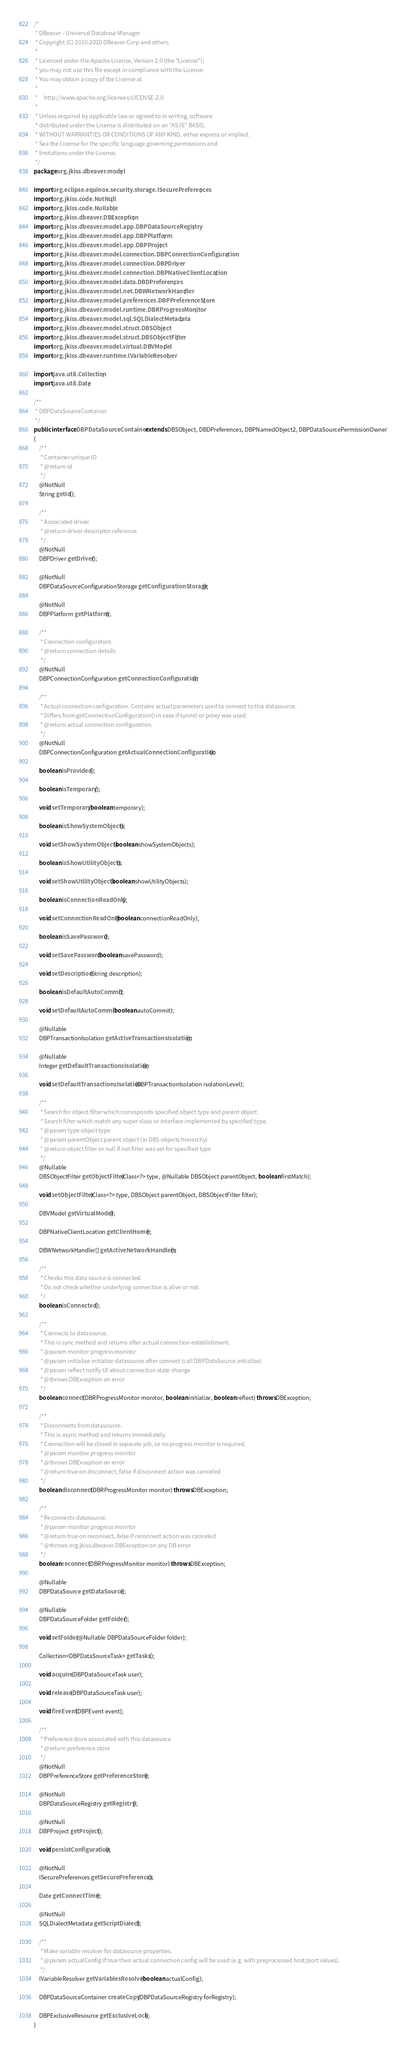<code> <loc_0><loc_0><loc_500><loc_500><_Java_>/*
 * DBeaver - Universal Database Manager
 * Copyright (C) 2010-2020 DBeaver Corp and others
 *
 * Licensed under the Apache License, Version 2.0 (the "License");
 * you may not use this file except in compliance with the License.
 * You may obtain a copy of the License at
 *
 *     http://www.apache.org/licenses/LICENSE-2.0
 *
 * Unless required by applicable law or agreed to in writing, software
 * distributed under the License is distributed on an "AS IS" BASIS,
 * WITHOUT WARRANTIES OR CONDITIONS OF ANY KIND, either express or implied.
 * See the License for the specific language governing permissions and
 * limitations under the License.
 */
package org.jkiss.dbeaver.model;

import org.eclipse.equinox.security.storage.ISecurePreferences;
import org.jkiss.code.NotNull;
import org.jkiss.code.Nullable;
import org.jkiss.dbeaver.DBException;
import org.jkiss.dbeaver.model.app.DBPDataSourceRegistry;
import org.jkiss.dbeaver.model.app.DBPPlatform;
import org.jkiss.dbeaver.model.app.DBPProject;
import org.jkiss.dbeaver.model.connection.DBPConnectionConfiguration;
import org.jkiss.dbeaver.model.connection.DBPDriver;
import org.jkiss.dbeaver.model.connection.DBPNativeClientLocation;
import org.jkiss.dbeaver.model.data.DBDPreferences;
import org.jkiss.dbeaver.model.net.DBWNetworkHandler;
import org.jkiss.dbeaver.model.preferences.DBPPreferenceStore;
import org.jkiss.dbeaver.model.runtime.DBRProgressMonitor;
import org.jkiss.dbeaver.model.sql.SQLDialectMetadata;
import org.jkiss.dbeaver.model.struct.DBSObject;
import org.jkiss.dbeaver.model.struct.DBSObjectFilter;
import org.jkiss.dbeaver.model.virtual.DBVModel;
import org.jkiss.dbeaver.runtime.IVariableResolver;

import java.util.Collection;
import java.util.Date;

/**
 * DBPDataSourceContainer
 */
public interface DBPDataSourceContainer extends DBSObject, DBDPreferences, DBPNamedObject2, DBPDataSourcePermissionOwner
{
    /**
     * Container unique ID
     * @return id
     */
    @NotNull
    String getId();

    /**
     * Associated driver
     * @return driver descriptor reference
     */
    @NotNull
    DBPDriver getDriver();

    @NotNull
    DBPDataSourceConfigurationStorage getConfigurationStorage();

    @NotNull
    DBPPlatform getPlatform();

    /**
     * Connection configuration.
     * @return connection details
     */
    @NotNull
    DBPConnectionConfiguration getConnectionConfiguration();

    /**
     * Actual connection configuration. Contains actual parameters used to connect to this datasource.
     * Differs from getConnectionConfiguration() in case if tunnel or proxy was used.
     * @return actual connection configuration.
     */
    @NotNull
    DBPConnectionConfiguration getActualConnectionConfiguration();

    boolean isProvided();

    boolean isTemporary();

    void setTemporary(boolean temporary);

    boolean isShowSystemObjects();

    void setShowSystemObjects(boolean showSystemObjects);

    boolean isShowUtilityObjects();

    void setShowUtilityObjects(boolean showUtilityObjects);

    boolean isConnectionReadOnly();

    void setConnectionReadOnly(boolean connectionReadOnly);

    boolean isSavePassword();

    void setSavePassword(boolean savePassword);

    void setDescription(String description);

    boolean isDefaultAutoCommit();

    void setDefaultAutoCommit(boolean autoCommit);

    @Nullable
    DBPTransactionIsolation getActiveTransactionsIsolation();

    @Nullable
    Integer getDefaultTransactionsIsolation();

    void setDefaultTransactionsIsolation(DBPTransactionIsolation isolationLevel);

    /**
     * Search for object filter which corresponds specified object type and parent object.
     * Search filter which match any super class or interface implemented by specified type.
     * @param type object type
     * @param parentObject parent object (in DBS objects hierarchy)
     * @return object filter or null if not filter was set for specified type
     */
    @Nullable
    DBSObjectFilter getObjectFilter(Class<?> type, @Nullable DBSObject parentObject, boolean firstMatch);

    void setObjectFilter(Class<?> type, DBSObject parentObject, DBSObjectFilter filter);

    DBVModel getVirtualModel();

    DBPNativeClientLocation getClientHome();

    DBWNetworkHandler[] getActiveNetworkHandlers();

    /**
     * Checks this data source is connected.
     * Do not check whether underlying connection is alive or not.
     */
    boolean isConnected();

    /**
     * Connects to datasource.
     * This is sync method and returns after actual connection establishment.
     * @param monitor progress monitor
     * @param initialize initialize datasource after connect (call DBPDataSource.initialize)
     * @param reflect notify UI about connection state change
     * @throws DBException on error
     */
    boolean connect(DBRProgressMonitor monitor, boolean initialize, boolean reflect) throws DBException;

    /**
     * Disconnects from datasource.
     * This is async method and returns immediately.
     * Connection will be closed in separate job, so no progress monitor is required.
     * @param monitor progress monitor
     * @throws DBException on error
     * @return true on disconnect, false if disconnect action was canceled
     */
    boolean disconnect(DBRProgressMonitor monitor) throws DBException;

    /**
     * Reconnects datasource.
     * @param monitor progress monitor
     * @return true on reconnect, false if reconnect action was canceled
     * @throws org.jkiss.dbeaver.DBException on any DB error
     */
    boolean reconnect(DBRProgressMonitor monitor) throws DBException;

    @Nullable
    DBPDataSource getDataSource();

    @Nullable
    DBPDataSourceFolder getFolder();

    void setFolder(@Nullable DBPDataSourceFolder folder);

    Collection<DBPDataSourceTask> getTasks();

    void acquire(DBPDataSourceTask user);

    void release(DBPDataSourceTask user);

    void fireEvent(DBPEvent event);

    /**
     * Preference store associated with this datasource
     * @return preference store
     */
    @NotNull
    DBPPreferenceStore getPreferenceStore();

    @NotNull
    DBPDataSourceRegistry getRegistry();

    @NotNull
    DBPProject getProject();

    void persistConfiguration();

    @NotNull
    ISecurePreferences getSecurePreferences();

    Date getConnectTime();

    @NotNull
    SQLDialectMetadata getScriptDialect();

    /**
     * Make variable resolver for datasource properties.
     * @param actualConfig if true then actual connection config will be used (e.g. with preprocessed host/port values).
     */
    IVariableResolver getVariablesResolver(boolean actualConfig);

    DBPDataSourceContainer createCopy(DBPDataSourceRegistry forRegistry);

    DBPExclusiveResource getExclusiveLock();
}
</code> 